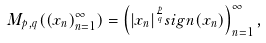Convert formula to latex. <formula><loc_0><loc_0><loc_500><loc_500>M _ { p , q } ( ( x _ { n } ) _ { n = 1 } ^ { \infty } ) = \left ( | x _ { n } | ^ { \frac { p } { q } } s i g n ( x _ { n } ) \right ) _ { n = 1 } ^ { \infty } ,</formula> 